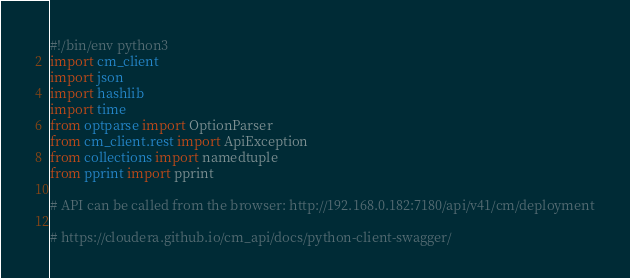<code> <loc_0><loc_0><loc_500><loc_500><_Python_>#!/bin/env python3 
import cm_client
import json
import hashlib
import time
from optparse import OptionParser
from cm_client.rest import ApiException
from collections import namedtuple
from pprint import pprint

# API can be called from the browser: http://192.168.0.182:7180/api/v41/cm/deployment

# https://cloudera.github.io/cm_api/docs/python-client-swagger/</code> 